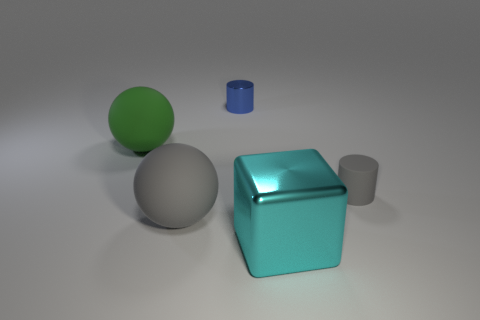Do the large thing in front of the gray sphere and the blue thing have the same material? While both the large aqua-colored cube in front of the gray sphere and the smaller blue cylinder share a reflective quality, suggesting they might be made of similar materials such as plastic or polished metal, their exact composition cannot be determined from the image alone. Details such as the presence of light reflections and shadows indicate that the surfaces are smooth and shiny, which often characterizes materials like polished stone, metal, or certain plastics. 